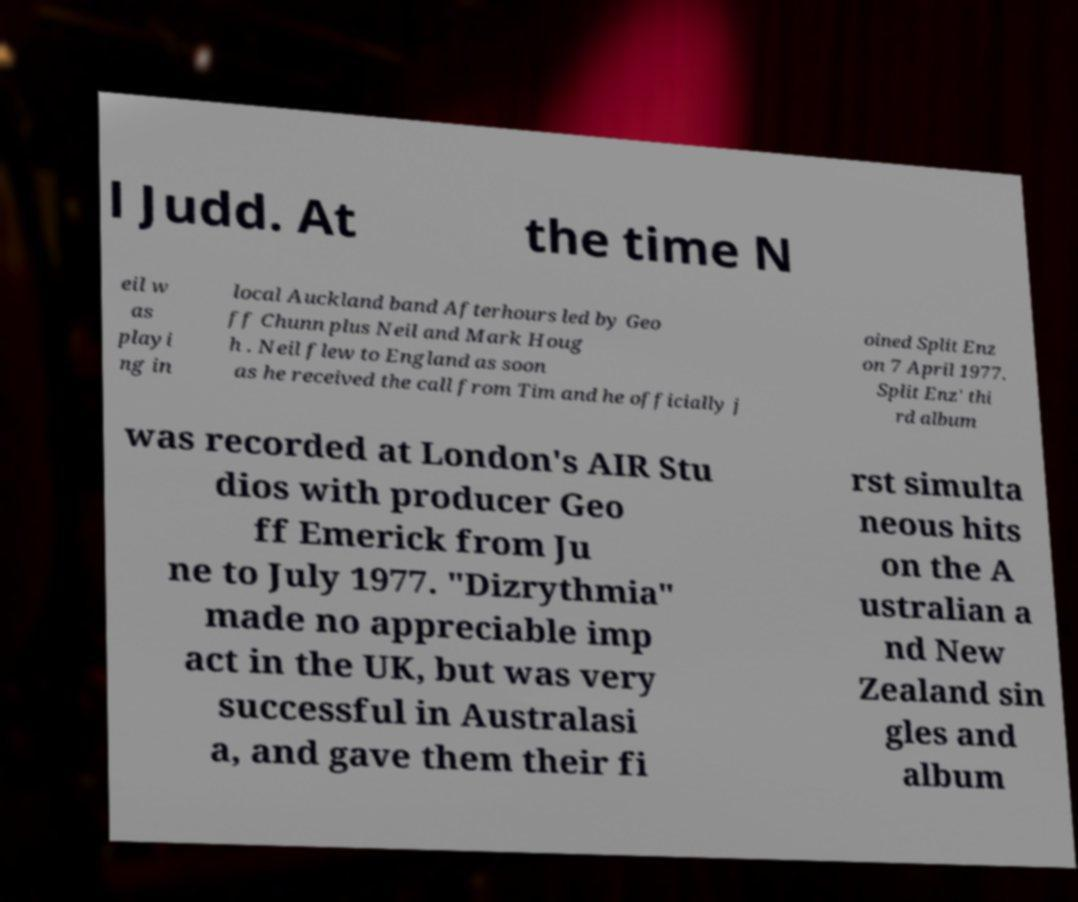There's text embedded in this image that I need extracted. Can you transcribe it verbatim? l Judd. At the time N eil w as playi ng in local Auckland band Afterhours led by Geo ff Chunn plus Neil and Mark Houg h . Neil flew to England as soon as he received the call from Tim and he officially j oined Split Enz on 7 April 1977. Split Enz' thi rd album was recorded at London's AIR Stu dios with producer Geo ff Emerick from Ju ne to July 1977. "Dizrythmia" made no appreciable imp act in the UK, but was very successful in Australasi a, and gave them their fi rst simulta neous hits on the A ustralian a nd New Zealand sin gles and album 